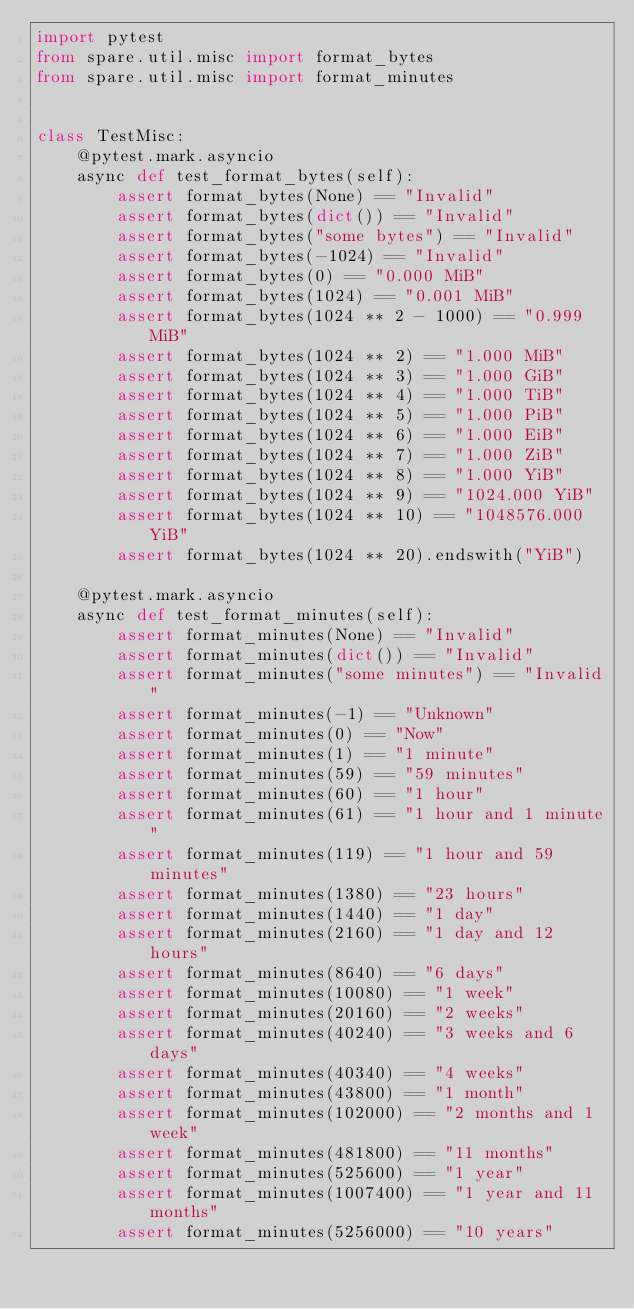Convert code to text. <code><loc_0><loc_0><loc_500><loc_500><_Python_>import pytest
from spare.util.misc import format_bytes
from spare.util.misc import format_minutes


class TestMisc:
    @pytest.mark.asyncio
    async def test_format_bytes(self):
        assert format_bytes(None) == "Invalid"
        assert format_bytes(dict()) == "Invalid"
        assert format_bytes("some bytes") == "Invalid"
        assert format_bytes(-1024) == "Invalid"
        assert format_bytes(0) == "0.000 MiB"
        assert format_bytes(1024) == "0.001 MiB"
        assert format_bytes(1024 ** 2 - 1000) == "0.999 MiB"
        assert format_bytes(1024 ** 2) == "1.000 MiB"
        assert format_bytes(1024 ** 3) == "1.000 GiB"
        assert format_bytes(1024 ** 4) == "1.000 TiB"
        assert format_bytes(1024 ** 5) == "1.000 PiB"
        assert format_bytes(1024 ** 6) == "1.000 EiB"
        assert format_bytes(1024 ** 7) == "1.000 ZiB"
        assert format_bytes(1024 ** 8) == "1.000 YiB"
        assert format_bytes(1024 ** 9) == "1024.000 YiB"
        assert format_bytes(1024 ** 10) == "1048576.000 YiB"
        assert format_bytes(1024 ** 20).endswith("YiB")

    @pytest.mark.asyncio
    async def test_format_minutes(self):
        assert format_minutes(None) == "Invalid"
        assert format_minutes(dict()) == "Invalid"
        assert format_minutes("some minutes") == "Invalid"
        assert format_minutes(-1) == "Unknown"
        assert format_minutes(0) == "Now"
        assert format_minutes(1) == "1 minute"
        assert format_minutes(59) == "59 minutes"
        assert format_minutes(60) == "1 hour"
        assert format_minutes(61) == "1 hour and 1 minute"
        assert format_minutes(119) == "1 hour and 59 minutes"
        assert format_minutes(1380) == "23 hours"
        assert format_minutes(1440) == "1 day"
        assert format_minutes(2160) == "1 day and 12 hours"
        assert format_minutes(8640) == "6 days"
        assert format_minutes(10080) == "1 week"
        assert format_minutes(20160) == "2 weeks"
        assert format_minutes(40240) == "3 weeks and 6 days"
        assert format_minutes(40340) == "4 weeks"
        assert format_minutes(43800) == "1 month"
        assert format_minutes(102000) == "2 months and 1 week"
        assert format_minutes(481800) == "11 months"
        assert format_minutes(525600) == "1 year"
        assert format_minutes(1007400) == "1 year and 11 months"
        assert format_minutes(5256000) == "10 years"
</code> 